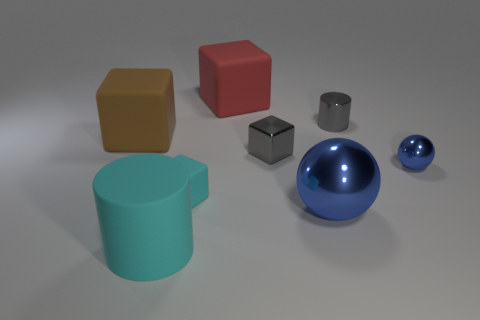Add 2 brown blocks. How many objects exist? 10 Subtract all spheres. How many objects are left? 6 Subtract 0 green cylinders. How many objects are left? 8 Subtract all large cyan things. Subtract all gray objects. How many objects are left? 5 Add 3 small gray cubes. How many small gray cubes are left? 4 Add 6 tiny gray metallic cubes. How many tiny gray metallic cubes exist? 7 